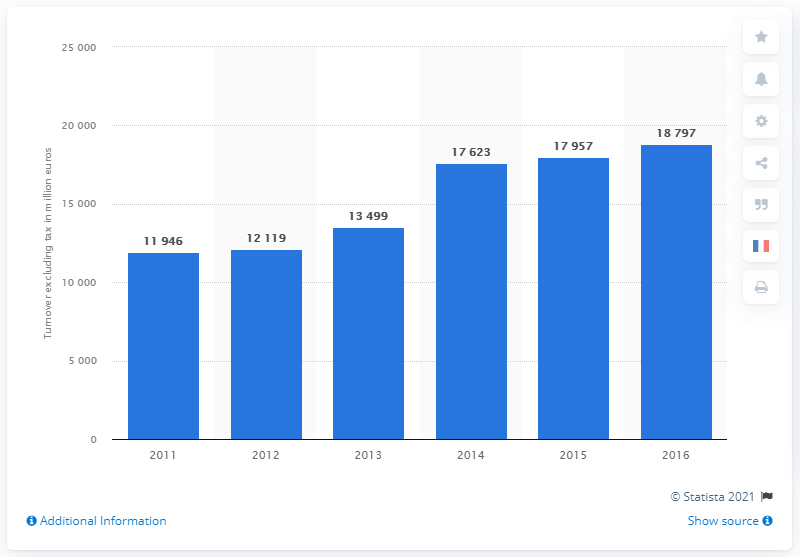Indicate a few pertinent items in this graphic. In 2014, the fast food service industry in France achieved its highest level of performance. 